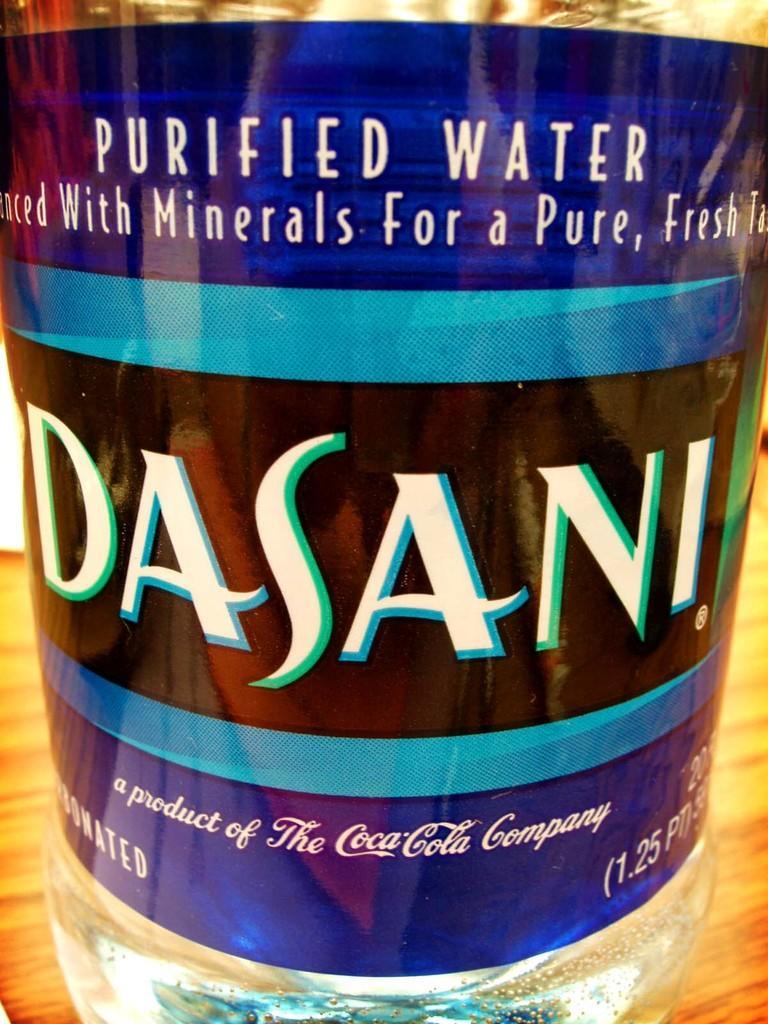Can you describe this image briefly? In this picture we can see a bottle. 